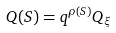<formula> <loc_0><loc_0><loc_500><loc_500>Q ( S ) = q ^ { \rho ( S ) } Q _ { \xi }</formula> 